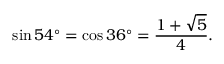Convert formula to latex. <formula><loc_0><loc_0><loc_500><loc_500>\sin 5 4 ^ { \circ } = \cos 3 6 ^ { \circ } = { \frac { 1 + { \sqrt { 5 } } } { 4 } } .</formula> 